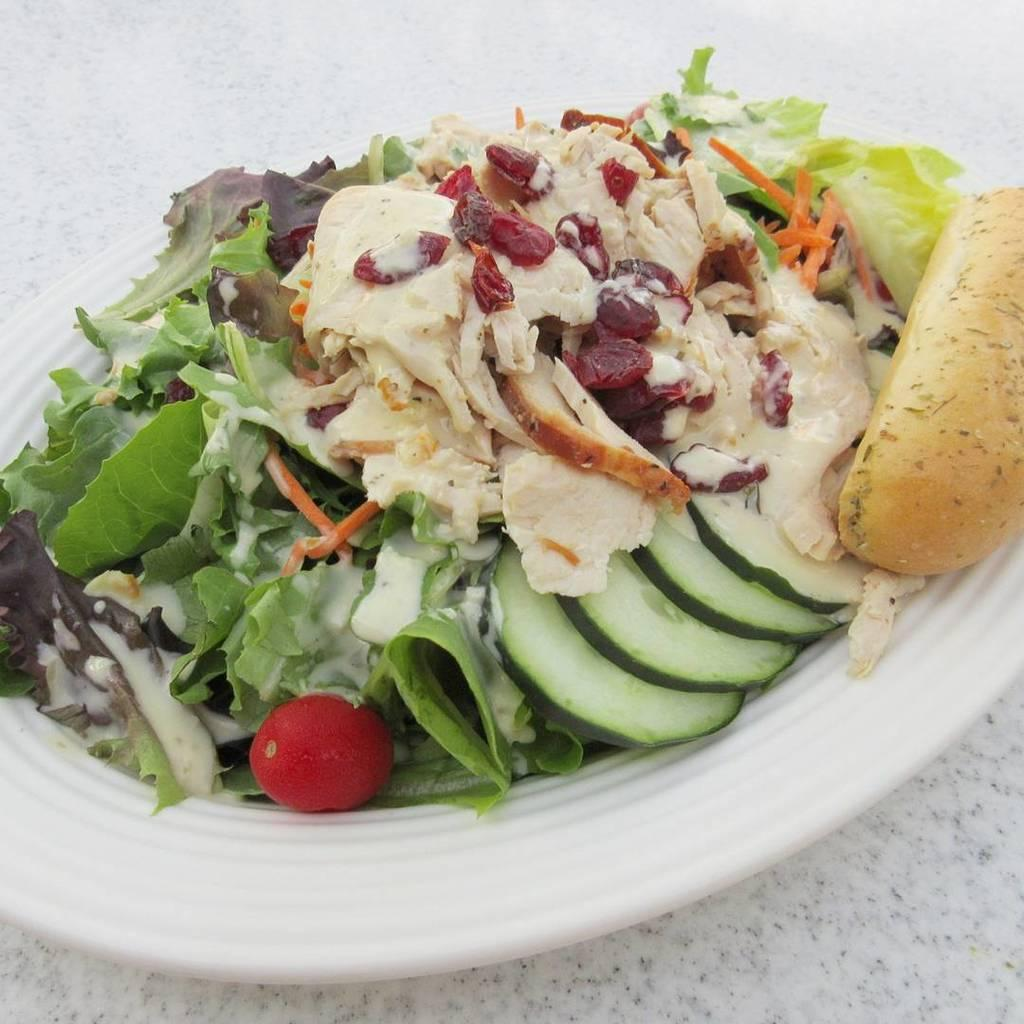What is on the plate in the image? The plate contains salad. What type of food is included in the salad? The salad consists of cut vegetables and leaves. What is the surface on which the plate is placed? The plate is placed on a white marble surface. How many oranges are on the plate in the image? There are no oranges present in the image. 